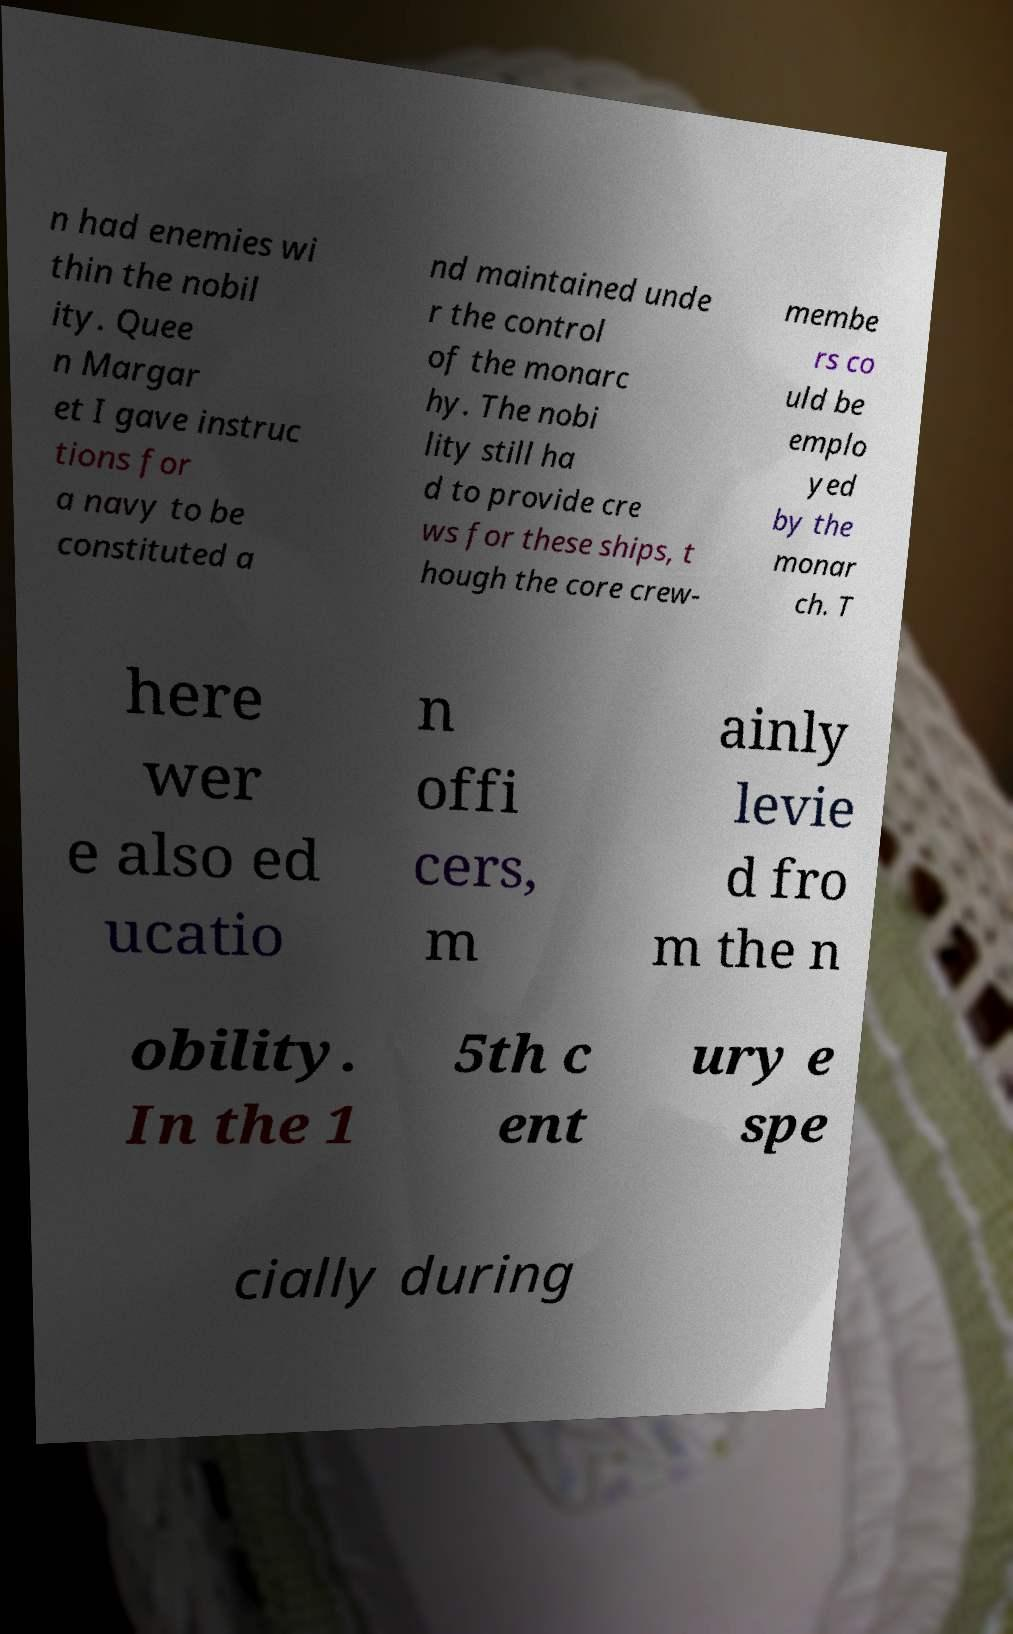I need the written content from this picture converted into text. Can you do that? n had enemies wi thin the nobil ity. Quee n Margar et I gave instruc tions for a navy to be constituted a nd maintained unde r the control of the monarc hy. The nobi lity still ha d to provide cre ws for these ships, t hough the core crew- membe rs co uld be emplo yed by the monar ch. T here wer e also ed ucatio n offi cers, m ainly levie d fro m the n obility. In the 1 5th c ent ury e spe cially during 